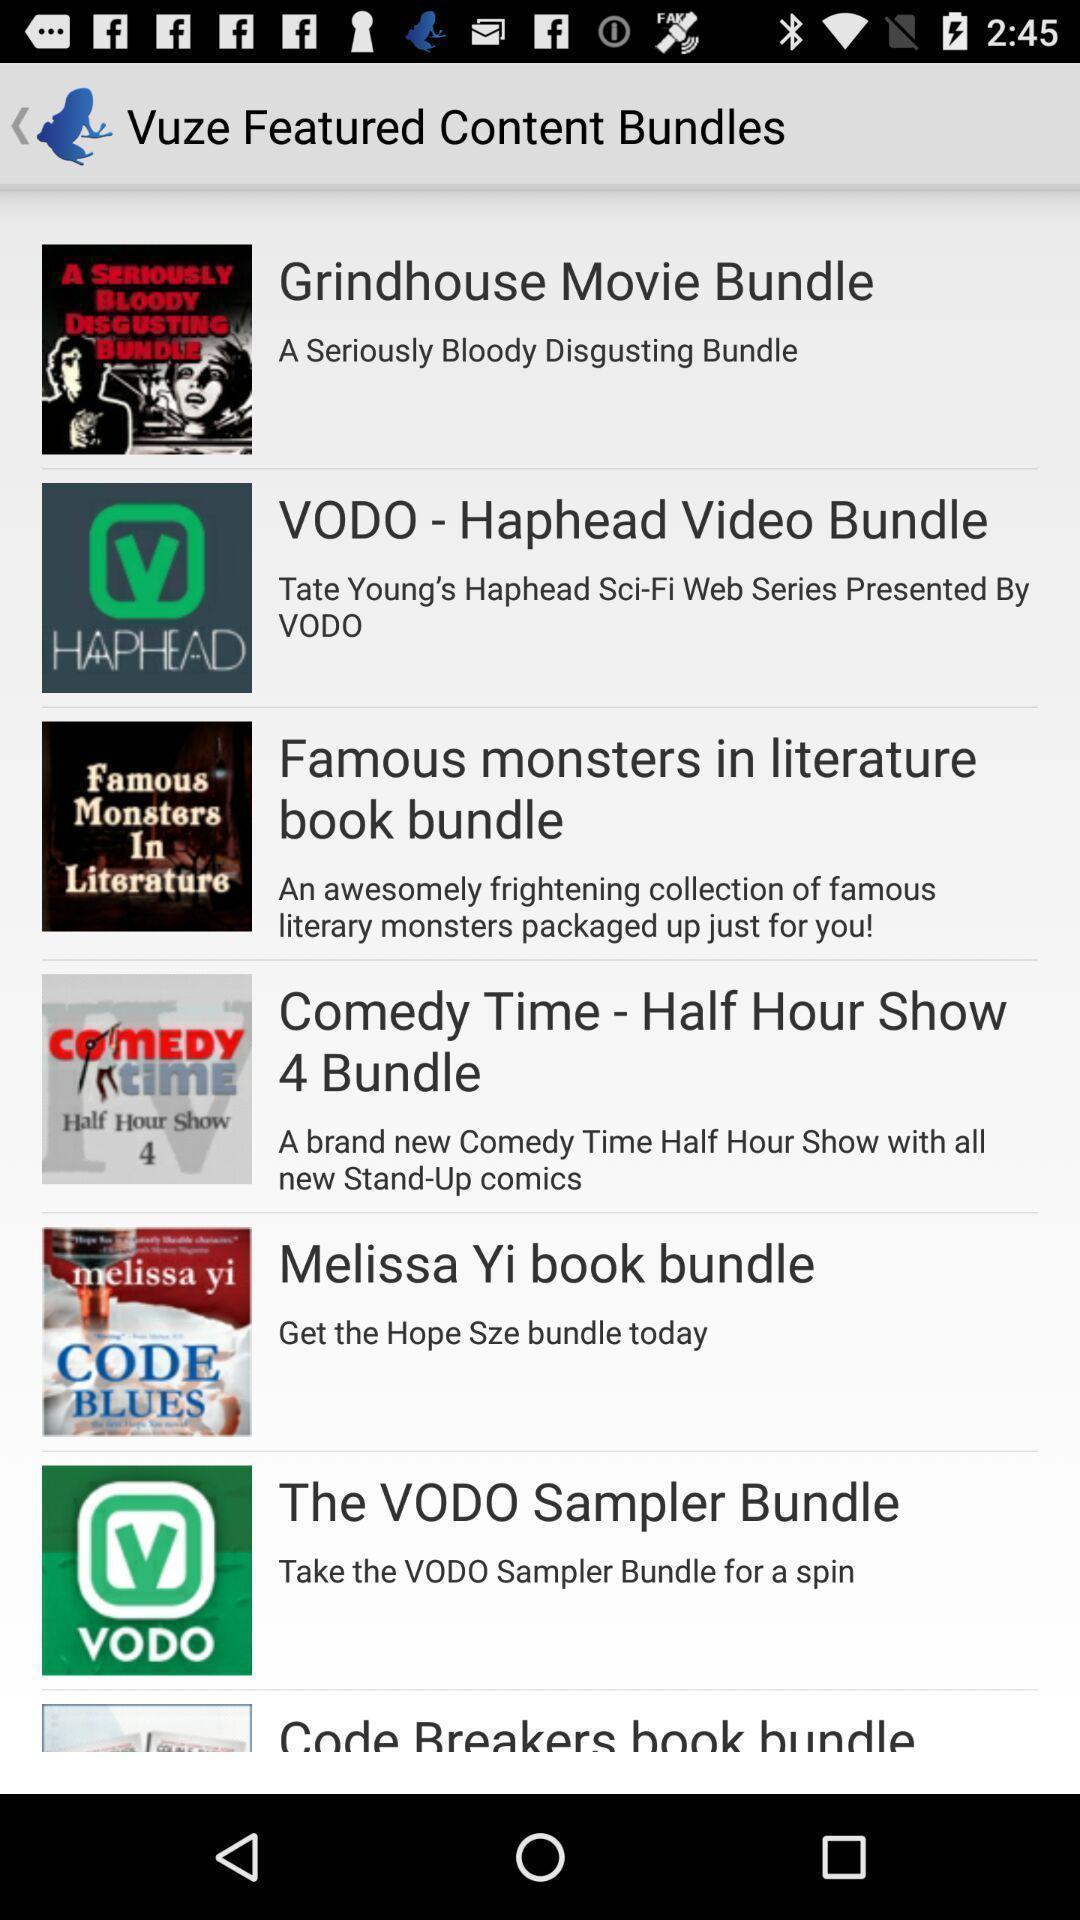What details can you identify in this image? Page displaying various content bundles. 